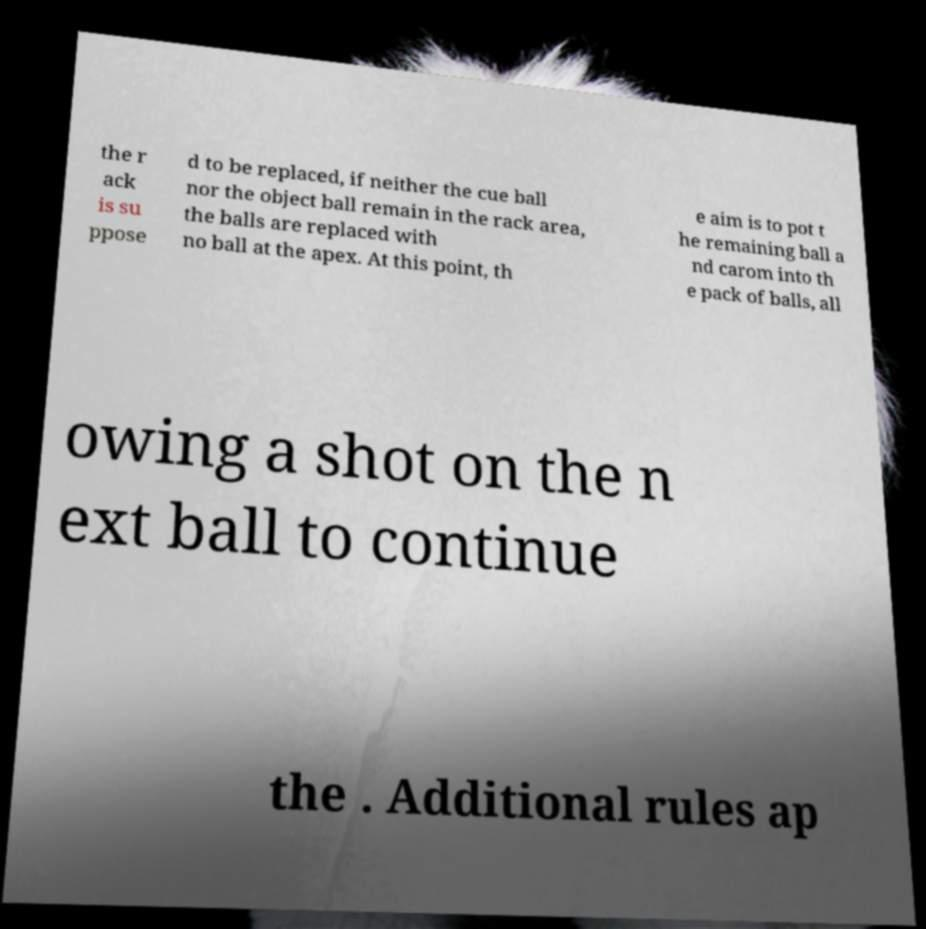For documentation purposes, I need the text within this image transcribed. Could you provide that? the r ack is su ppose d to be replaced, if neither the cue ball nor the object ball remain in the rack area, the balls are replaced with no ball at the apex. At this point, th e aim is to pot t he remaining ball a nd carom into th e pack of balls, all owing a shot on the n ext ball to continue the . Additional rules ap 